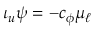<formula> <loc_0><loc_0><loc_500><loc_500>\iota _ { u } \psi = - c _ { \phi } \mu _ { \ell }</formula> 